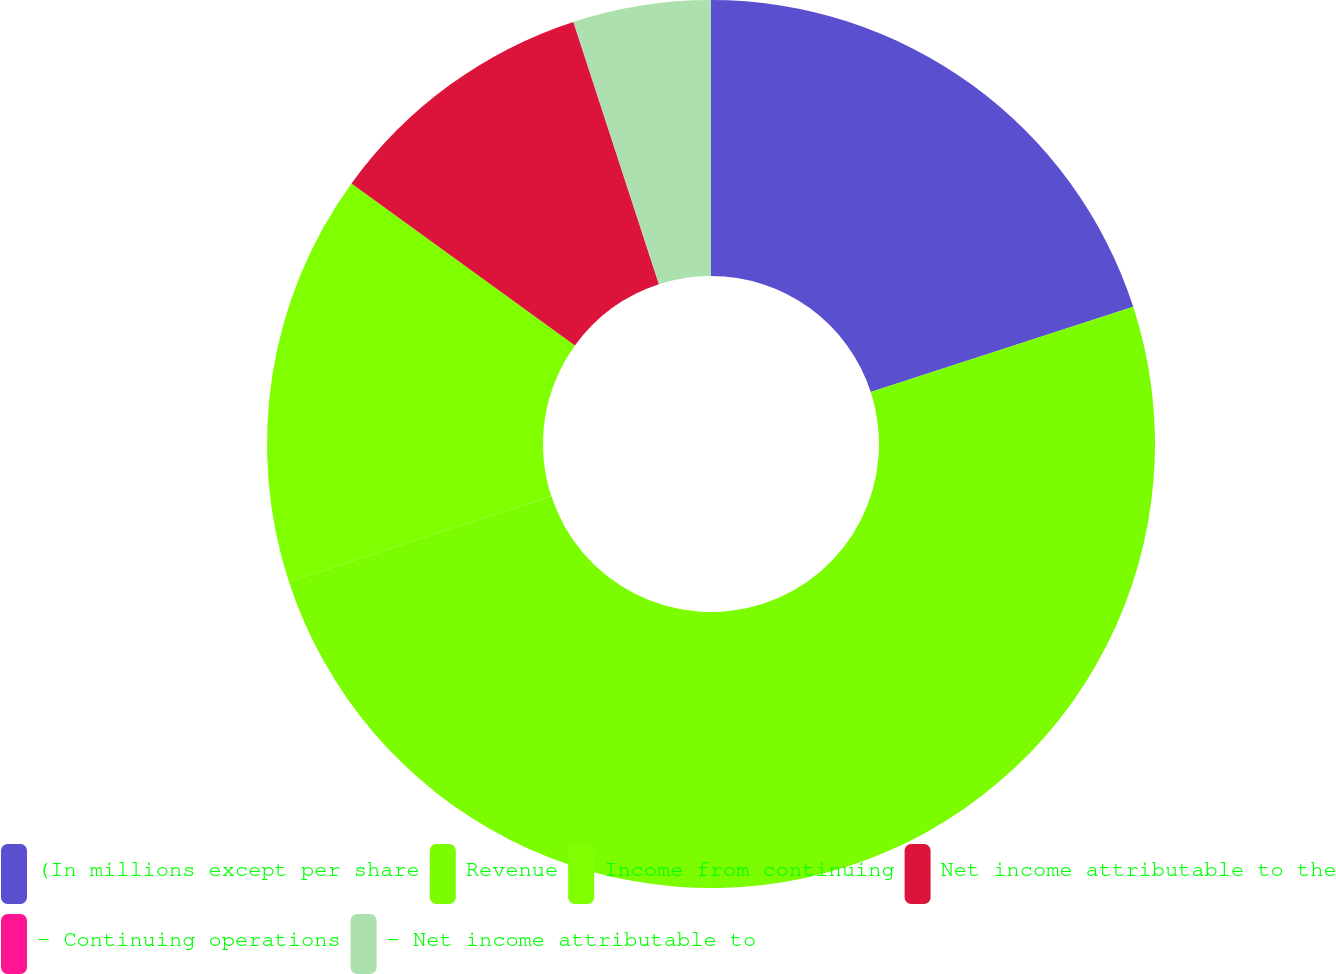Convert chart to OTSL. <chart><loc_0><loc_0><loc_500><loc_500><pie_chart><fcel>(In millions except per share<fcel>Revenue<fcel>Income from continuing<fcel>Net income attributable to the<fcel>- Continuing operations<fcel>- Net income attributable to<nl><fcel>20.0%<fcel>49.98%<fcel>15.0%<fcel>10.0%<fcel>0.01%<fcel>5.01%<nl></chart> 